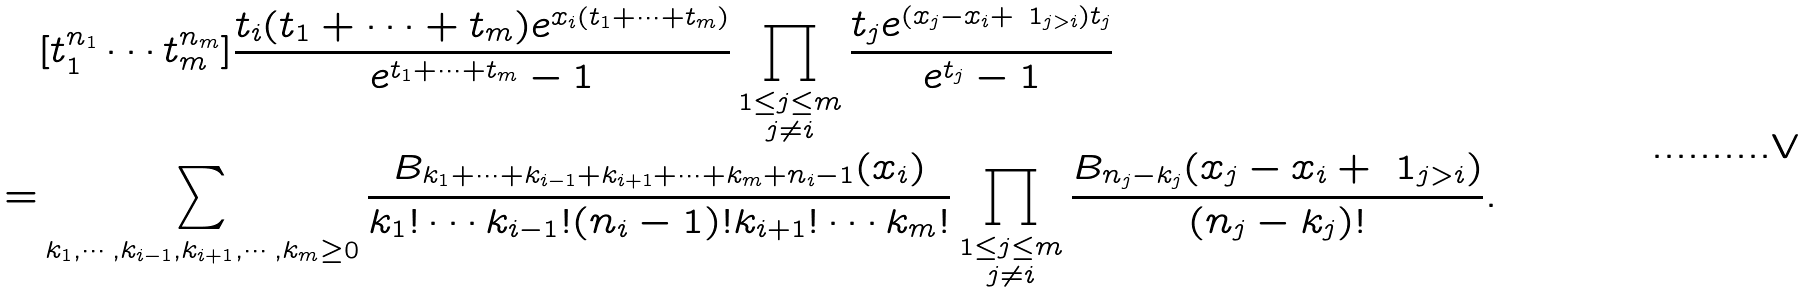<formula> <loc_0><loc_0><loc_500><loc_500>& [ t _ { 1 } ^ { n _ { 1 } } \cdots t _ { m } ^ { n _ { m } } ] \frac { t _ { i } ( t _ { 1 } + \cdots + t _ { m } ) e ^ { x _ { i } ( t _ { 1 } + \cdots + t _ { m } ) } } { e ^ { t _ { 1 } + \cdots + t _ { m } } - 1 } \prod _ { \substack { 1 \leq j \leq m \\ j \not = i } } \frac { t _ { j } e ^ { ( x _ { j } - x _ { i } + \ 1 _ { j > i } ) t _ { j } } } { e ^ { t _ { j } } - 1 } \\ = & \sum _ { \substack { k _ { 1 } , \cdots , k _ { i - 1 } , k _ { i + 1 } , \cdots , k _ { m } \geq 0 } } \frac { B _ { k _ { 1 } + \dots + k _ { i - 1 } + k _ { i + 1 } + \dots + k _ { m } + n _ { i } - 1 } ( x _ { i } ) } { k _ { 1 } ! \cdots k _ { i - 1 } ! ( n _ { i } - 1 ) ! k _ { i + 1 } ! \cdots k _ { m } ! } \prod _ { \substack { 1 \leq j \leq m \\ j \not = i } } \frac { B _ { n _ { j } - k _ { j } } ( x _ { j } - x _ { i } + \ 1 _ { j > i } ) } { ( n _ { j } - k _ { j } ) ! } .</formula> 